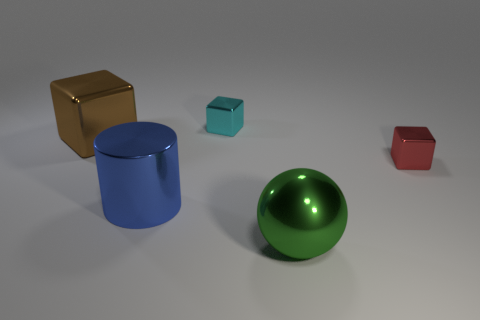What number of other big spheres have the same material as the sphere?
Offer a terse response. 0. How many gray things are either tiny metallic blocks or large spheres?
Make the answer very short. 0. How many objects are either small red metallic things or small metal cubes to the left of the small red thing?
Provide a succinct answer. 2. There is a tiny thing that is to the left of the big object to the right of the cylinder; how many cylinders are on the right side of it?
Your answer should be compact. 0. There is a big thing that is to the right of the blue shiny cylinder; is it the same shape as the brown thing?
Ensure brevity in your answer.  No. There is a thing behind the big brown metal cube; are there any large blue cylinders that are to the left of it?
Keep it short and to the point. Yes. How many big things are there?
Make the answer very short. 3. What color is the metallic block that is both to the right of the brown thing and on the left side of the small red block?
Keep it short and to the point. Cyan. What is the size of the red object that is the same shape as the tiny cyan object?
Offer a very short reply. Small. How many brown metallic blocks have the same size as the blue cylinder?
Offer a terse response. 1. 